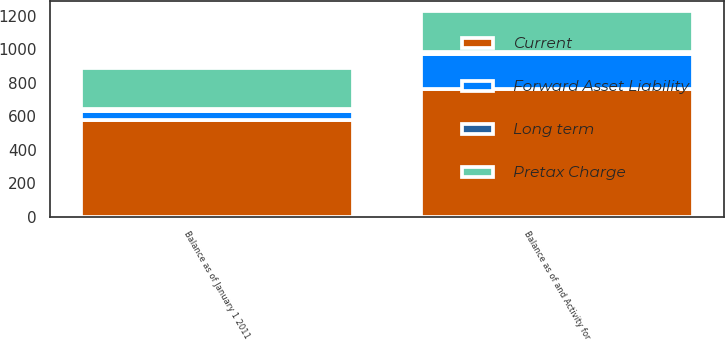Convert chart to OTSL. <chart><loc_0><loc_0><loc_500><loc_500><stacked_bar_chart><ecel><fcel>Balance as of January 1 2011<fcel>Balance as of and Activity for<nl><fcel>Current<fcel>578<fcel>763<nl><fcel>Pretax Charge<fcel>243<fcel>245<nl><fcel>Forward Asset Liability<fcel>55<fcel>207<nl><fcel>Long term<fcel>12<fcel>11<nl></chart> 